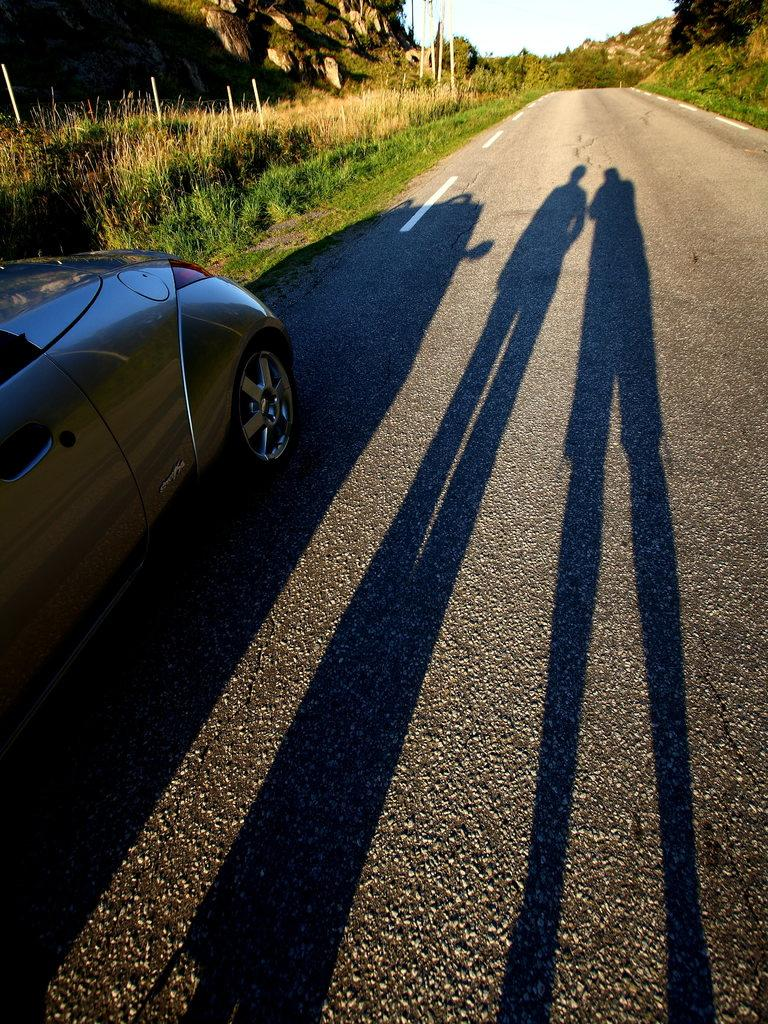What is the main subject of the image? There is a car on the road in the image. Can you identify any other people or objects in the image? Yes, there are shadows of two persons in the image. What type of vegetation is present on either side of the road? There are plants on either side of the road in the image. What can be seen in the background of the image? There are mountains and the sky visible in the background of the image. What type of error can be seen in the image? There is no error present in the image. What is the rod used for in the image? There is no rod present in the image. 